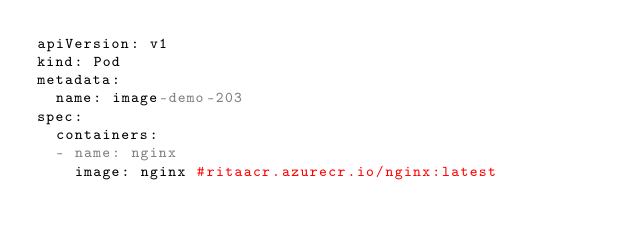Convert code to text. <code><loc_0><loc_0><loc_500><loc_500><_YAML_>apiVersion: v1
kind: Pod
metadata:
  name: image-demo-203
spec:
  containers:
  - name: nginx
    image: nginx #ritaacr.azurecr.io/nginx:latest</code> 